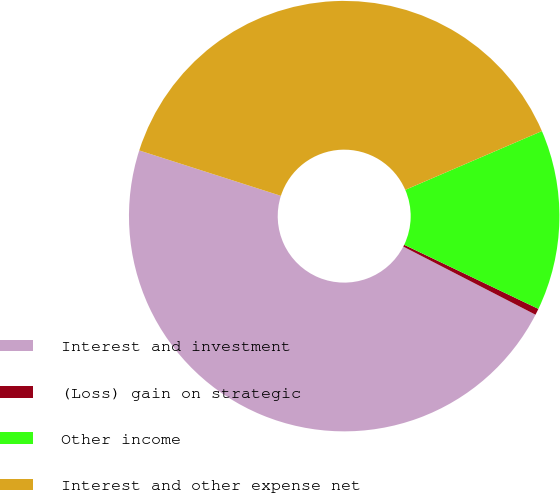Convert chart. <chart><loc_0><loc_0><loc_500><loc_500><pie_chart><fcel>Interest and investment<fcel>(Loss) gain on strategic<fcel>Other income<fcel>Interest and other expense net<nl><fcel>47.37%<fcel>0.48%<fcel>13.56%<fcel>38.6%<nl></chart> 